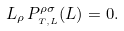Convert formula to latex. <formula><loc_0><loc_0><loc_500><loc_500>L _ { \rho } \, P ^ { \rho \sigma } _ { _ { T , L } } ( L ) = 0 .</formula> 